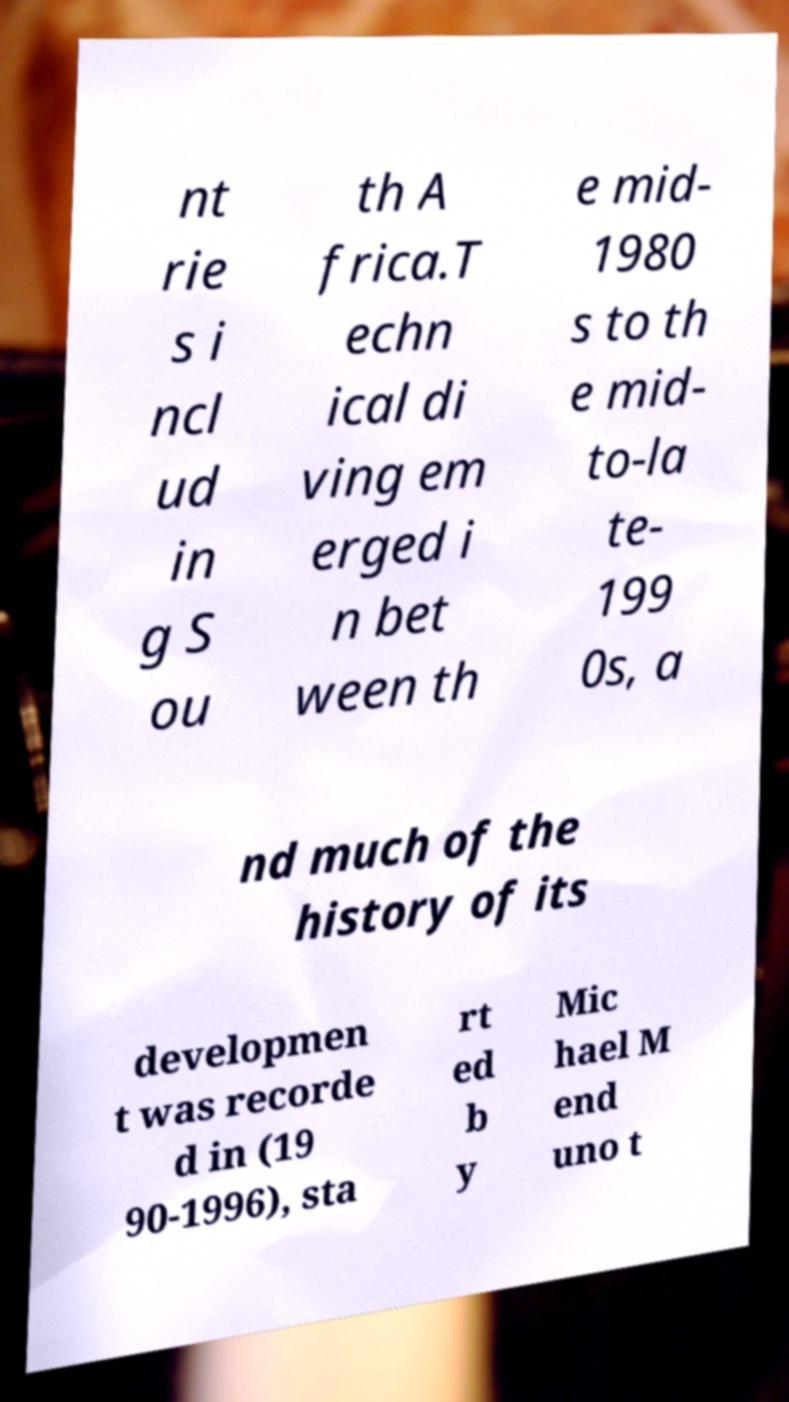Can you accurately transcribe the text from the provided image for me? nt rie s i ncl ud in g S ou th A frica.T echn ical di ving em erged i n bet ween th e mid- 1980 s to th e mid- to-la te- 199 0s, a nd much of the history of its developmen t was recorde d in (19 90-1996), sta rt ed b y Mic hael M end uno t 